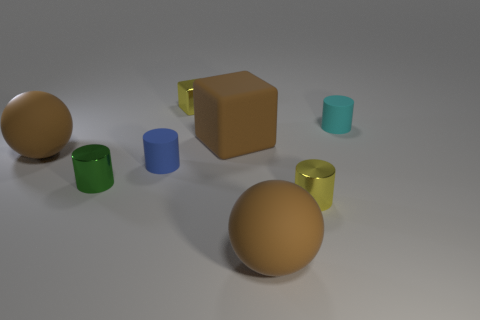The big rubber object that is left of the tiny shiny thing to the left of the small object that is behind the tiny cyan cylinder is what color?
Your answer should be very brief. Brown. How many balls are tiny green metal things or large brown objects?
Offer a very short reply. 2. What material is the cylinder that is the same color as the tiny block?
Provide a succinct answer. Metal. There is a large cube; does it have the same color as the ball that is on the left side of the small shiny block?
Give a very brief answer. Yes. The rubber cube is what color?
Your response must be concise. Brown. What number of things are tiny metal spheres or tiny yellow cubes?
Provide a short and direct response. 1. There is a green cylinder that is the same size as the blue rubber cylinder; what is its material?
Provide a short and direct response. Metal. What size is the yellow metallic thing in front of the tiny blue rubber object?
Make the answer very short. Small. What is the small yellow cylinder made of?
Your answer should be very brief. Metal. What number of things are large brown objects right of the brown matte block or cylinders in front of the big brown block?
Your response must be concise. 4. 